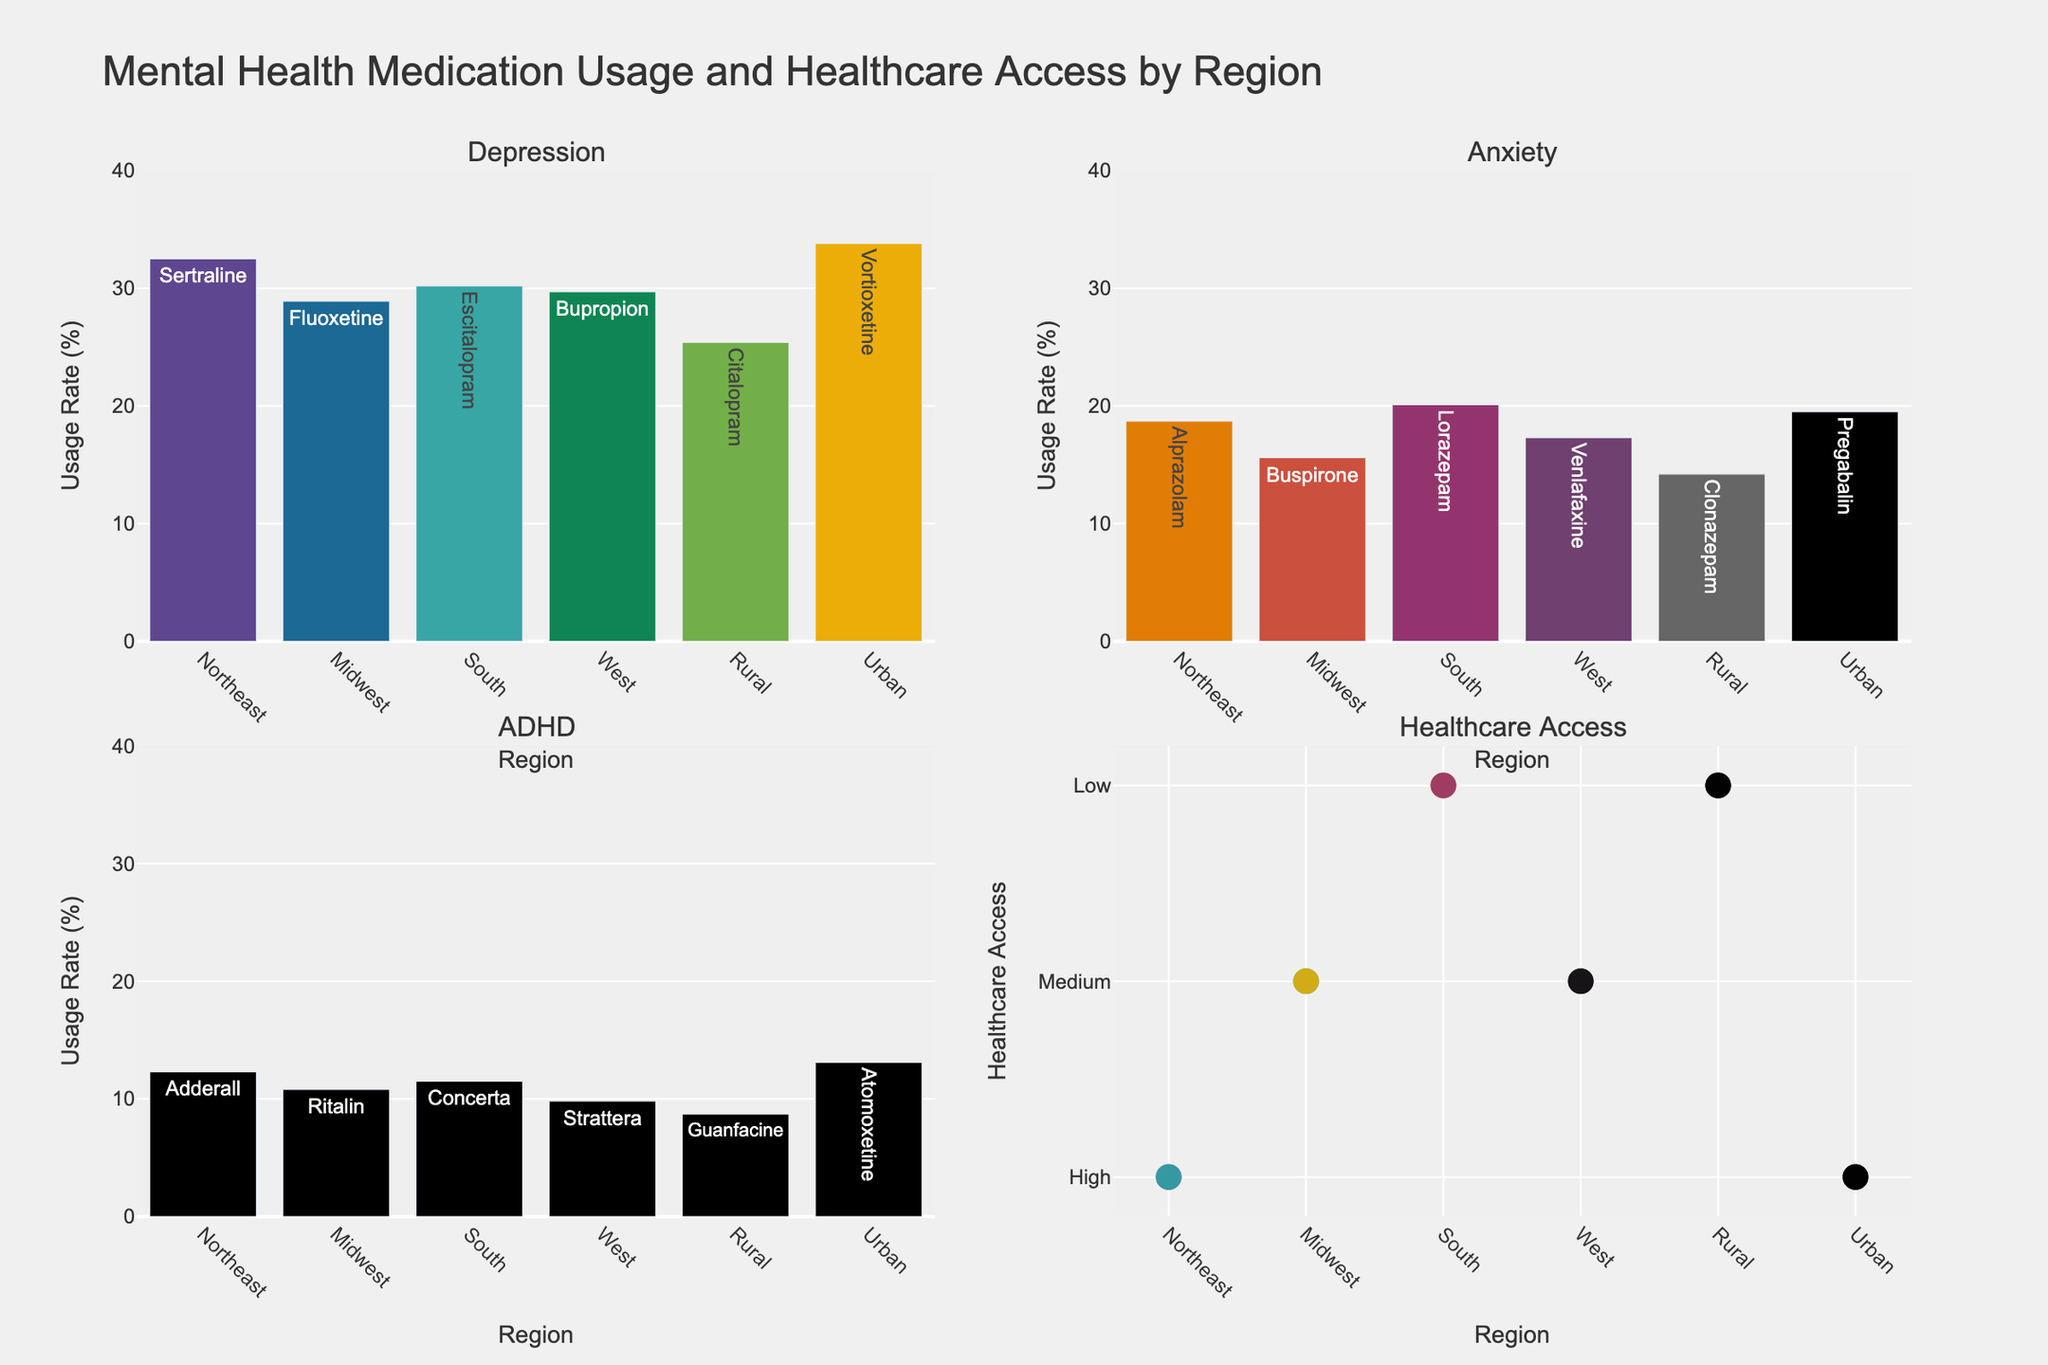How many regions have high healthcare access? There are four data points in the "Healthcare Access" subplot marked as "High." By visually inspecting the markers, we can observe that the regions with high healthcare access are the Northeast and Urban areas.
Answer: 2 Which region has the highest medication usage rate for depression? In the "Depression" subplot, the bar representing the Urban region has the highest value. By examining the bars' heights, we can see that the Urban area's usage rate is the highest at 33.8%.
Answer: Urban What is the overall trend in anxiety medication usage across regions? In the "Anxiety" subplot, we observe varying heights of bars representing different regions. By comparing the bars, the Urban region has the highest usage rate (19.5%), followed by the South (20.1%), Northeast (18.7%), then the West (17.3%), Midwest (15.6%), and lastly, the Rural region (14.2%). This indicates that Urban and South regions have higher usage rates.
Answer: Urban and South have higher usage Which region has the lowest medication usage rate for ADHD? In the "ADHD" subplot, the bar for the Rural region is the shortest, indicating the lowest usage rate of 8.7%. By visually comparing the bars' lengths, we can identify this.
Answer: Rural Is there a relationship between healthcare access and medication usage rate? By comparing the "Healthcare Access" subplot to the others, regions with high healthcare access (Northeast and Urban) generally show higher medication usage rates in the bar plots for depression, anxiety, and ADHD. This suggests a positive correlation between healthcare access and medication usage rate.
Answer: Positive correlation What is the difference in depression medication usage rates between the Midwest and the West? In the "Depression" subplot, the Midwest's bar is 28.9% and the West's bar is 29.7%. Subtracting these values gives the difference: 29.7% - 28.9% = 0.8%.
Answer: 0.8% Which condition shows the smallest range in medication usage rates across regions? By examining the heights of bars in each condition subplot, ADHD shows the smallest variation. The differences between the highest (Urban-13.1%) and the lowest (Rural-8.7%) usage rates are smaller compared to the other conditions.
Answer: ADHD What medication is most commonly used for anxiety in the Northeast? In the "Anxiety" subplot, the bar for the Northeast region lists Alprazolam when hovered over. This indicates it is the medication most commonly used for anxiety there.
Answer: Alprazolam Which region has medium healthcare access but lower medication usage rates for both depression and anxiety? The "Healthcare Access" subplot identifies Midwest and West as regions with medium healthcare access. Comparing medication usage rates in the "Depression" and "Anxiety" subplots, the Midwest region has lower usage rates (28.9% for depression, 15.6% for anxiety) compared to the West.
Answer: Midwest 